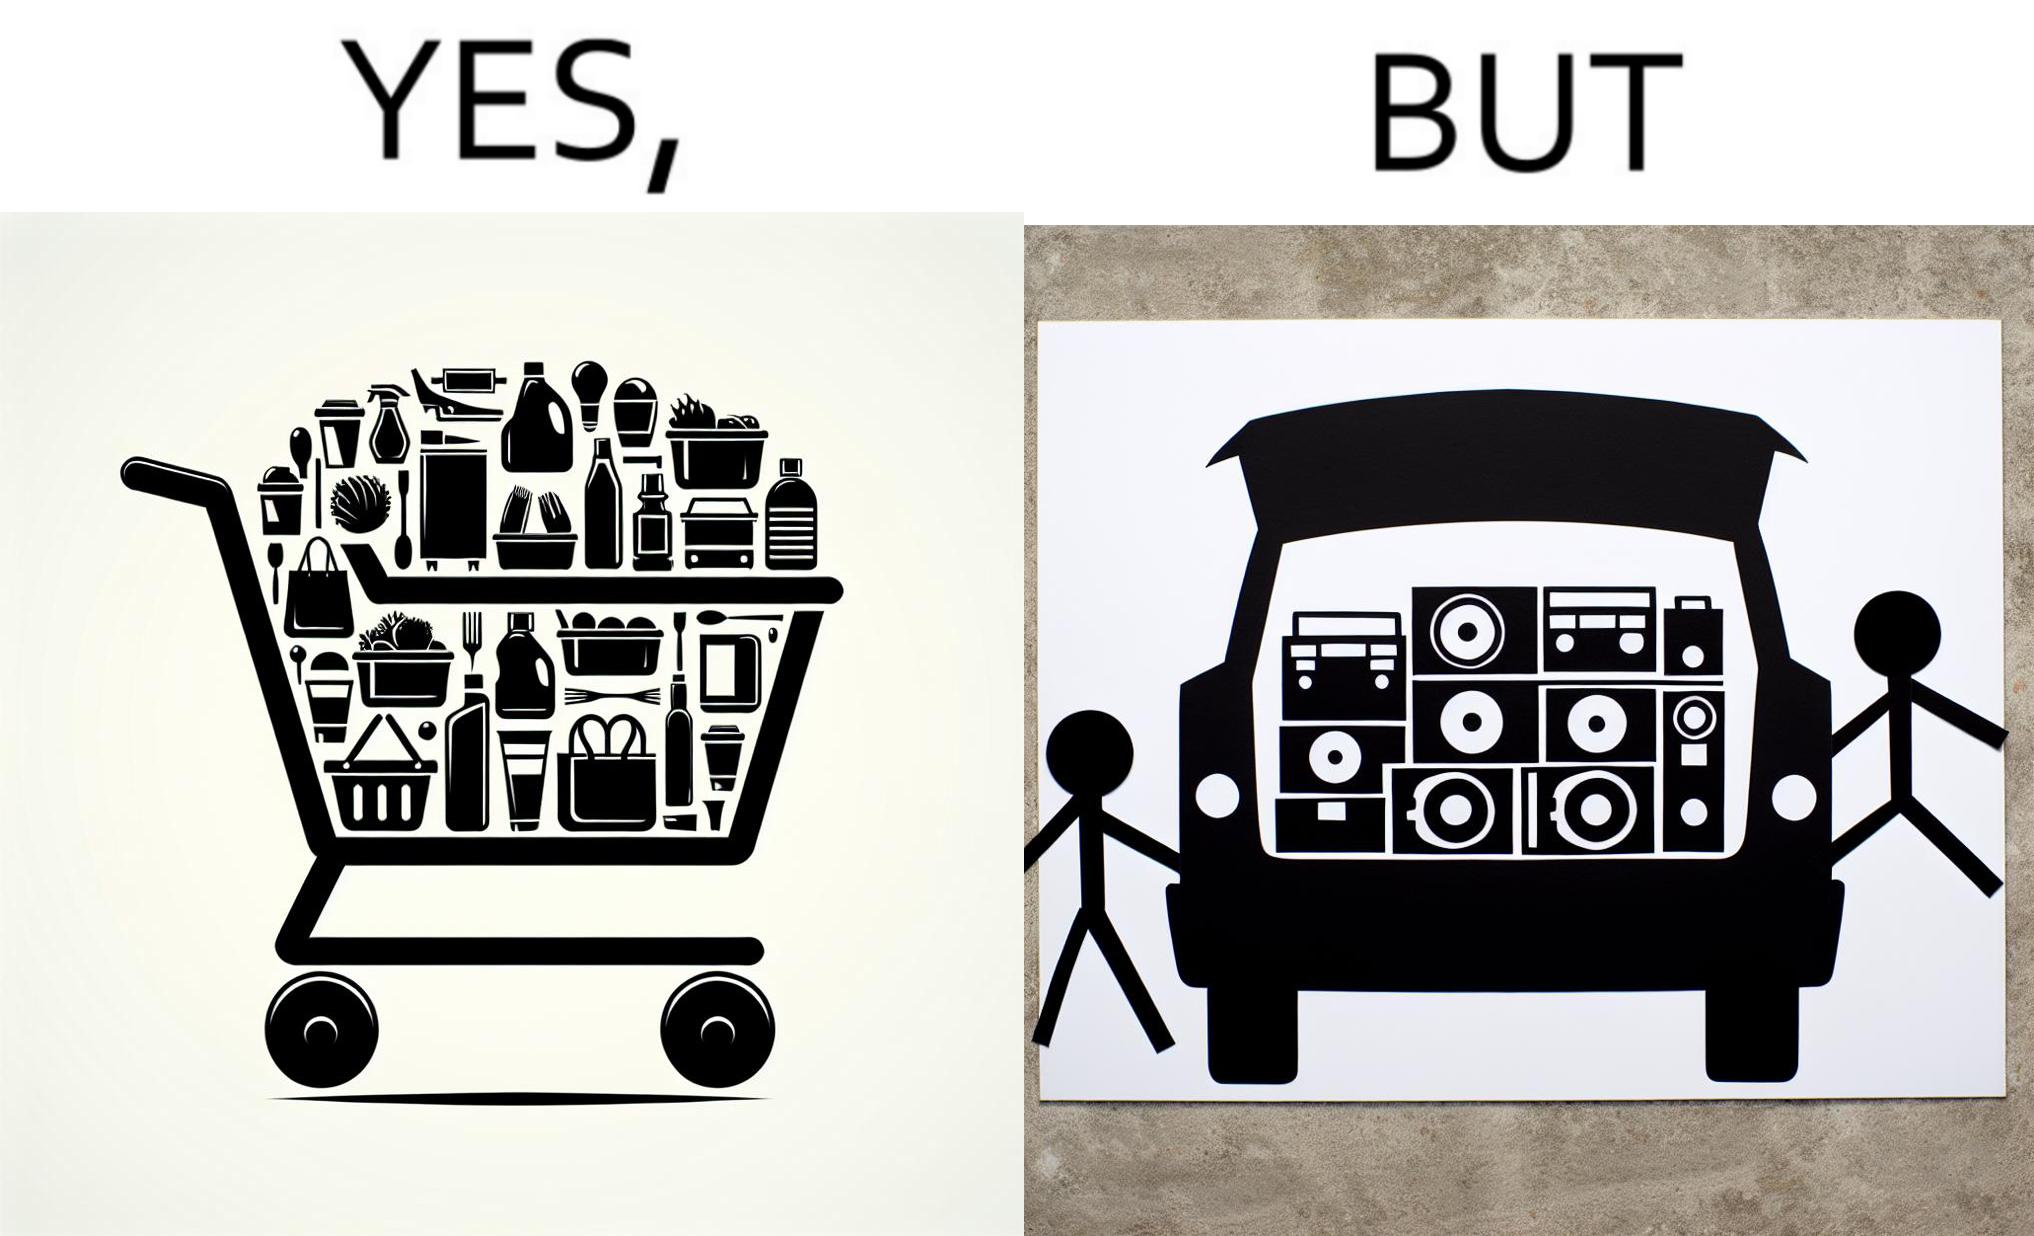Is this image satirical or non-satirical? Yes, this image is satirical. 